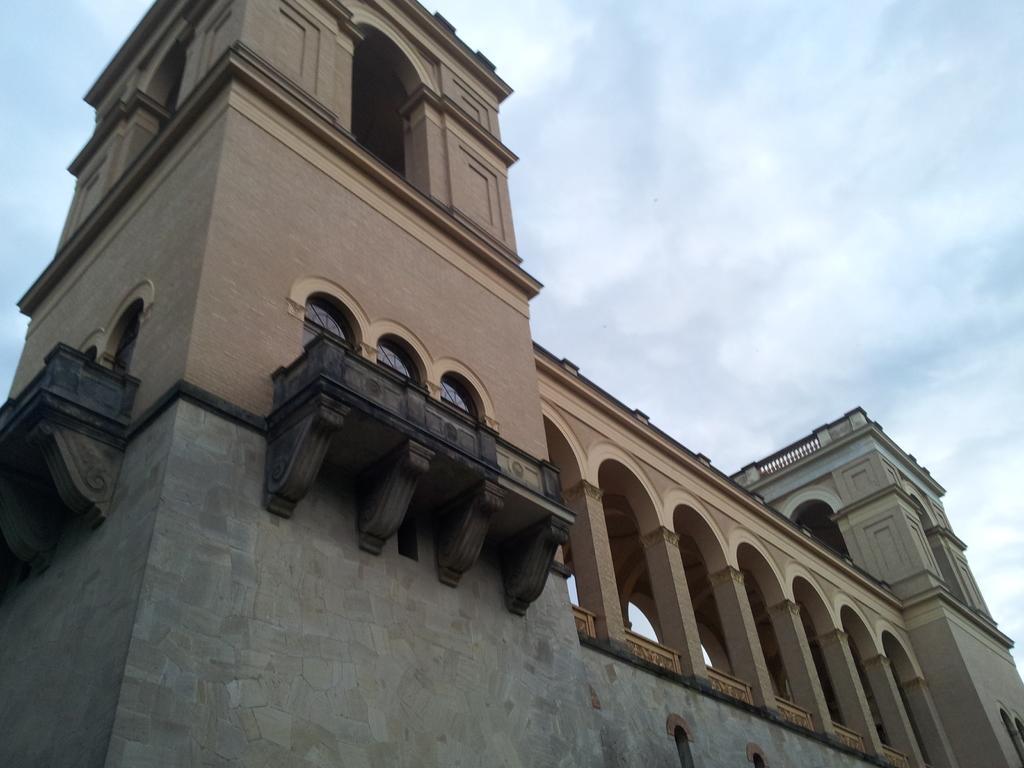Describe this image in one or two sentences. This picture might be taken outside of the building. In this image, we can see pillars, window. On the top, we can see a sky. 